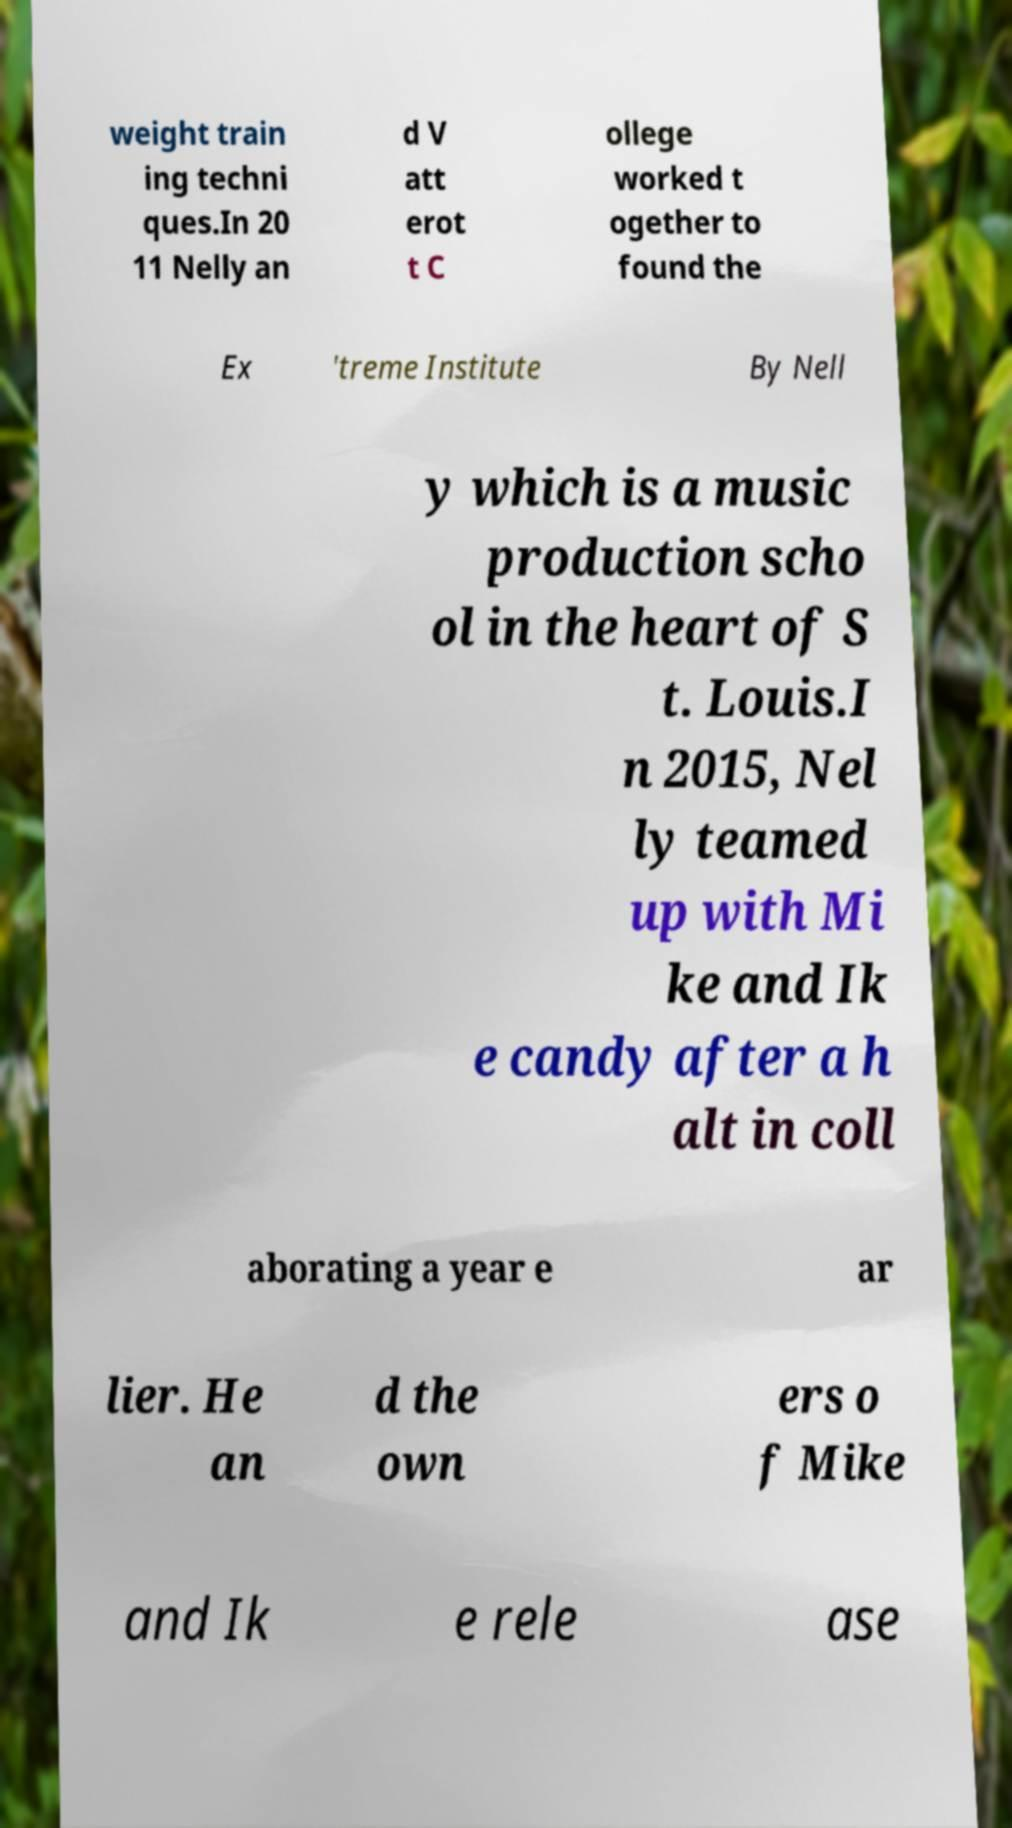Can you accurately transcribe the text from the provided image for me? weight train ing techni ques.In 20 11 Nelly an d V att erot t C ollege worked t ogether to found the Ex 'treme Institute By Nell y which is a music production scho ol in the heart of S t. Louis.I n 2015, Nel ly teamed up with Mi ke and Ik e candy after a h alt in coll aborating a year e ar lier. He an d the own ers o f Mike and Ik e rele ase 